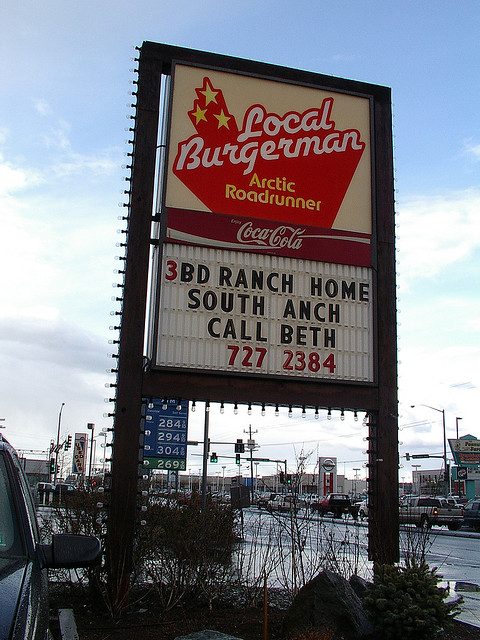Identify the text displayed in this image. 3BD RANCH HOME SOUTH ANCH 284 294 304 269 2384 727 BETH CALL Local Burgerman Arctic Arctic Roadrunner Coca-Cola 